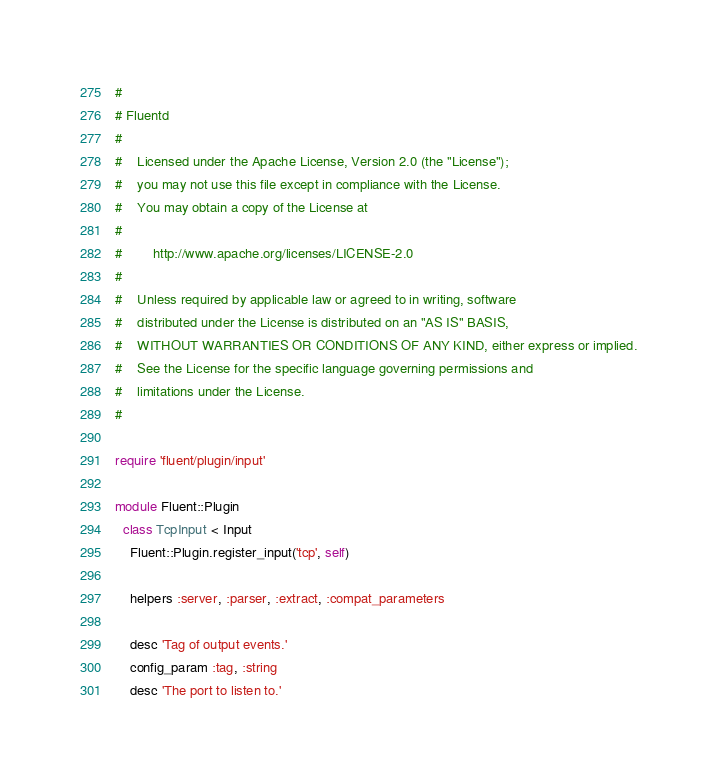Convert code to text. <code><loc_0><loc_0><loc_500><loc_500><_Ruby_>#
# Fluentd
#
#    Licensed under the Apache License, Version 2.0 (the "License");
#    you may not use this file except in compliance with the License.
#    You may obtain a copy of the License at
#
#        http://www.apache.org/licenses/LICENSE-2.0
#
#    Unless required by applicable law or agreed to in writing, software
#    distributed under the License is distributed on an "AS IS" BASIS,
#    WITHOUT WARRANTIES OR CONDITIONS OF ANY KIND, either express or implied.
#    See the License for the specific language governing permissions and
#    limitations under the License.
#

require 'fluent/plugin/input'

module Fluent::Plugin
  class TcpInput < Input
    Fluent::Plugin.register_input('tcp', self)

    helpers :server, :parser, :extract, :compat_parameters

    desc 'Tag of output events.'
    config_param :tag, :string
    desc 'The port to listen to.'</code> 